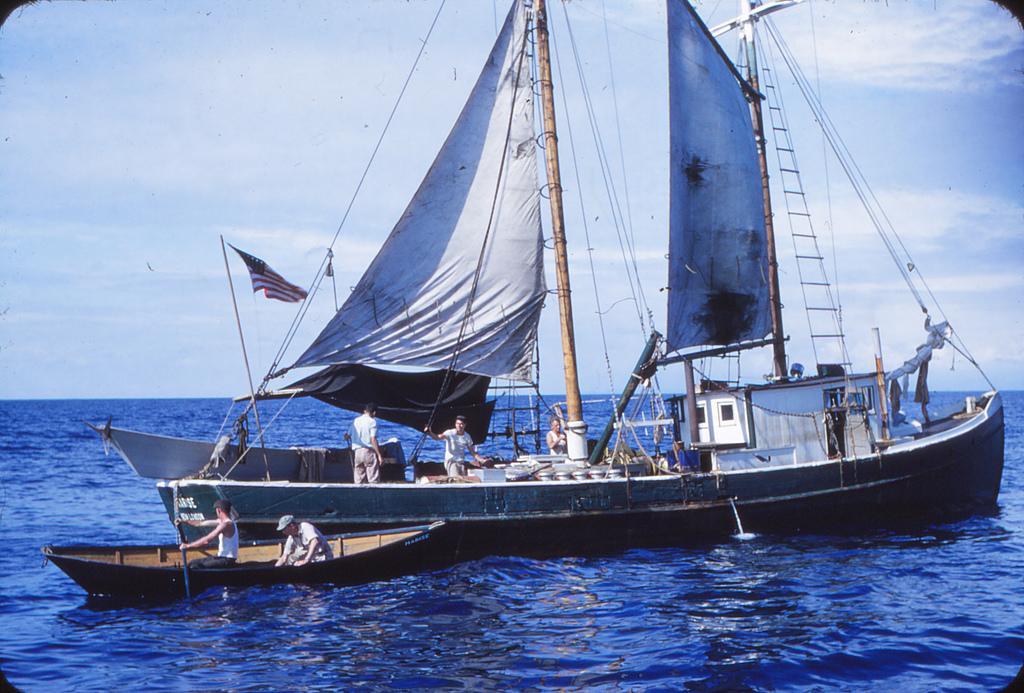Describe this image in one or two sentences. In this image I can see water and in it I can see few boats. On these boats I can see number of people, a flag, wires, few poles, white colour clothes and in background I can see in the sky. 